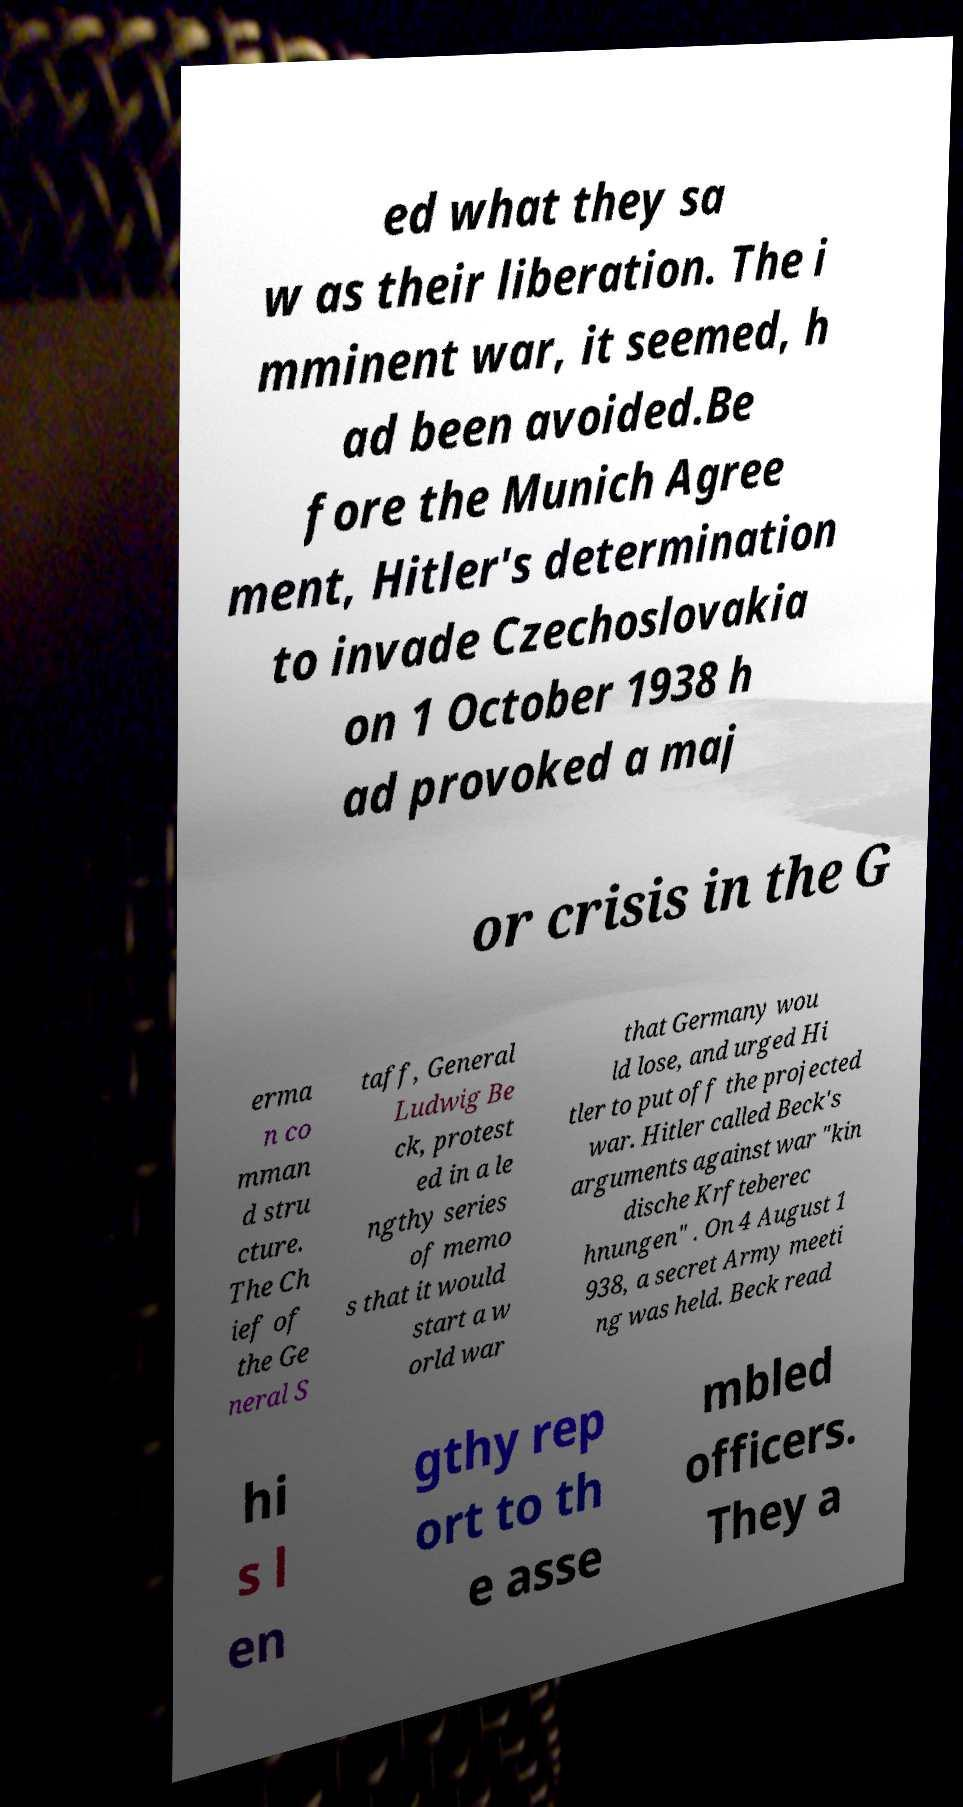Could you assist in decoding the text presented in this image and type it out clearly? ed what they sa w as their liberation. The i mminent war, it seemed, h ad been avoided.Be fore the Munich Agree ment, Hitler's determination to invade Czechoslovakia on 1 October 1938 h ad provoked a maj or crisis in the G erma n co mman d stru cture. The Ch ief of the Ge neral S taff, General Ludwig Be ck, protest ed in a le ngthy series of memo s that it would start a w orld war that Germany wou ld lose, and urged Hi tler to put off the projected war. Hitler called Beck's arguments against war "kin dische Krfteberec hnungen" . On 4 August 1 938, a secret Army meeti ng was held. Beck read hi s l en gthy rep ort to th e asse mbled officers. They a 